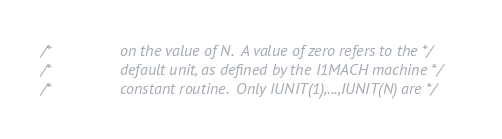<code> <loc_0><loc_0><loc_500><loc_500><_C_>/*                on the value of N.  A value of zero refers to the */
/*                default unit, as defined by the I1MACH machine */
/*                constant routine.  Only IUNIT(1),...,IUNIT(N) are */</code> 